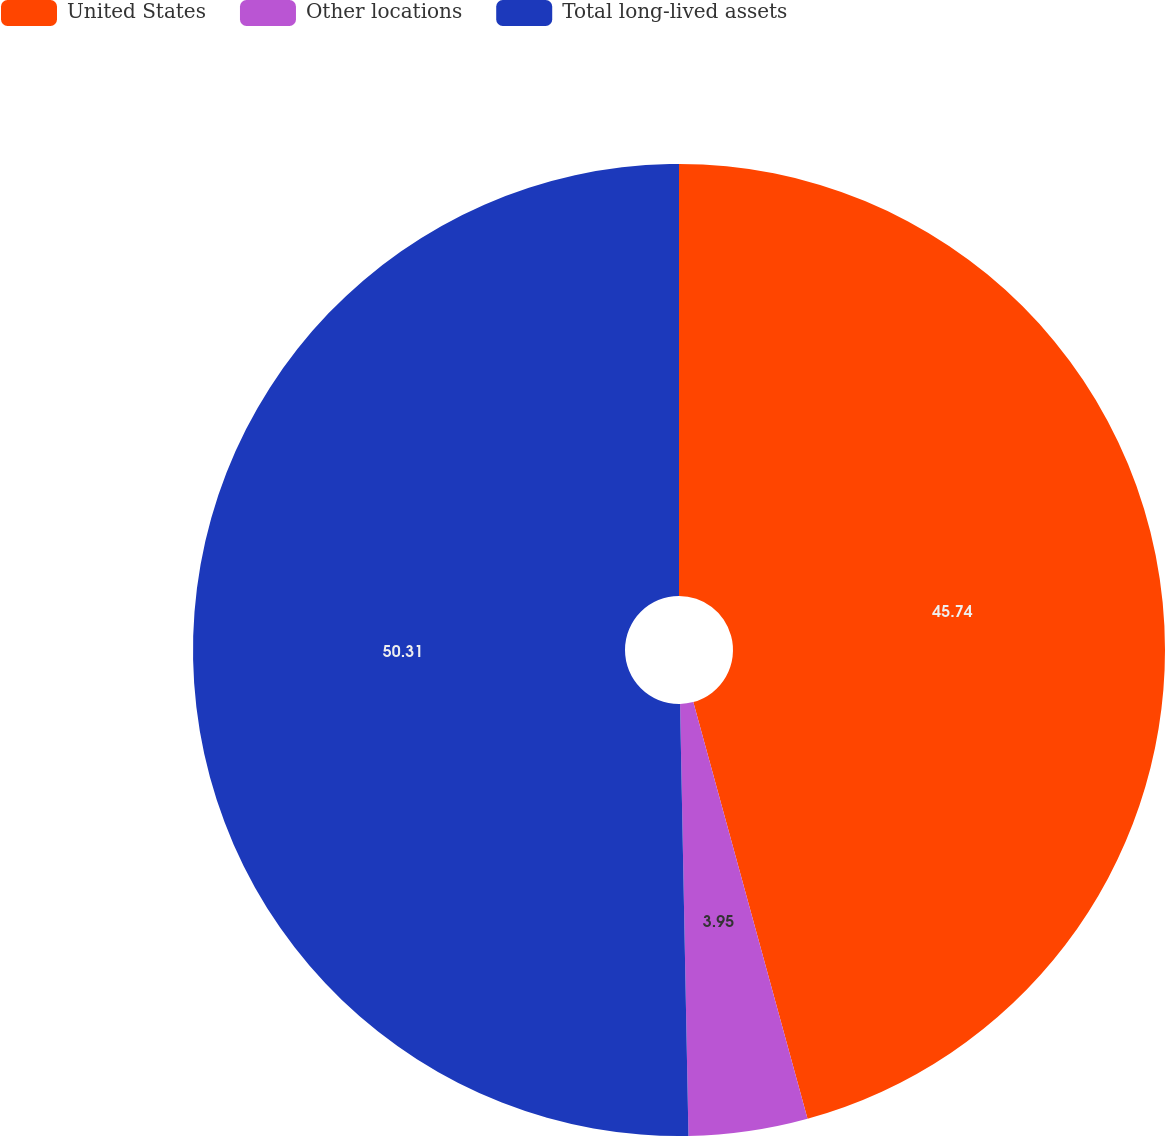Convert chart to OTSL. <chart><loc_0><loc_0><loc_500><loc_500><pie_chart><fcel>United States<fcel>Other locations<fcel>Total long-lived assets<nl><fcel>45.74%<fcel>3.95%<fcel>50.31%<nl></chart> 